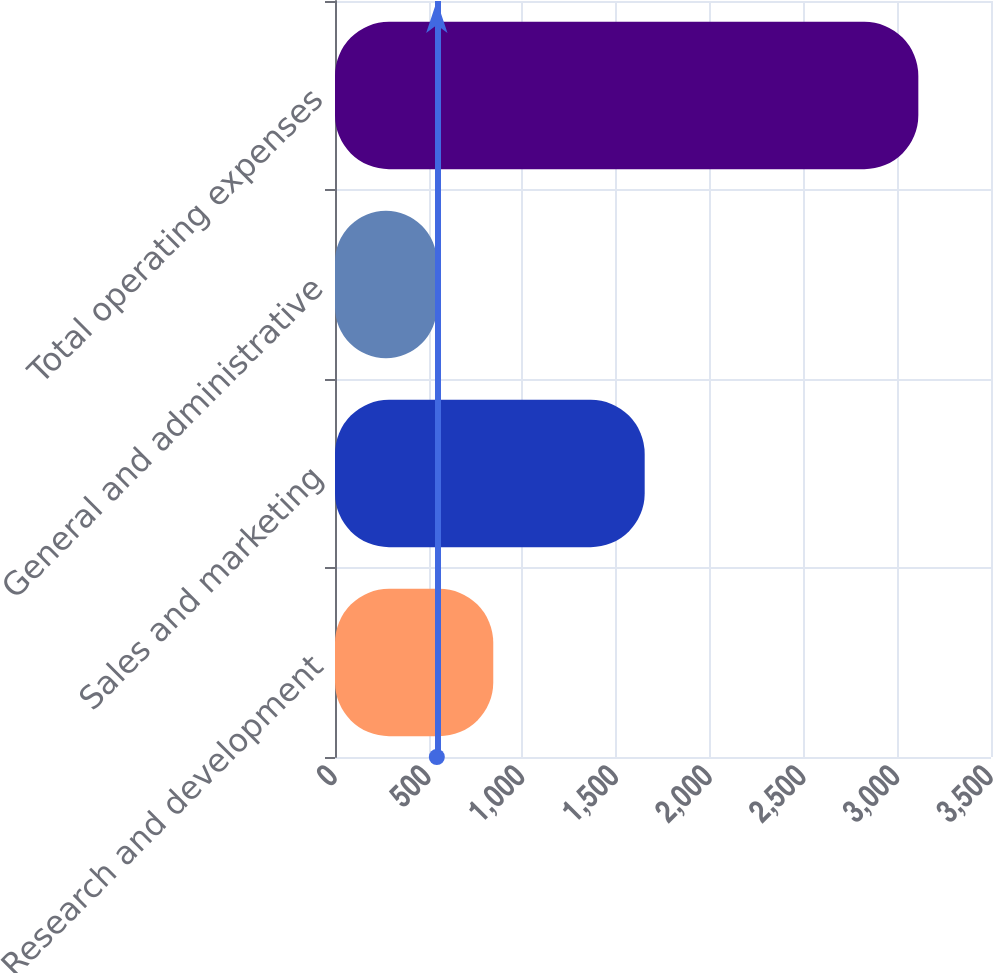Convert chart. <chart><loc_0><loc_0><loc_500><loc_500><bar_chart><fcel>Research and development<fcel>Sales and marketing<fcel>General and administrative<fcel>Total operating expenses<nl><fcel>844.4<fcel>1652.3<fcel>543.3<fcel>3112.3<nl></chart> 